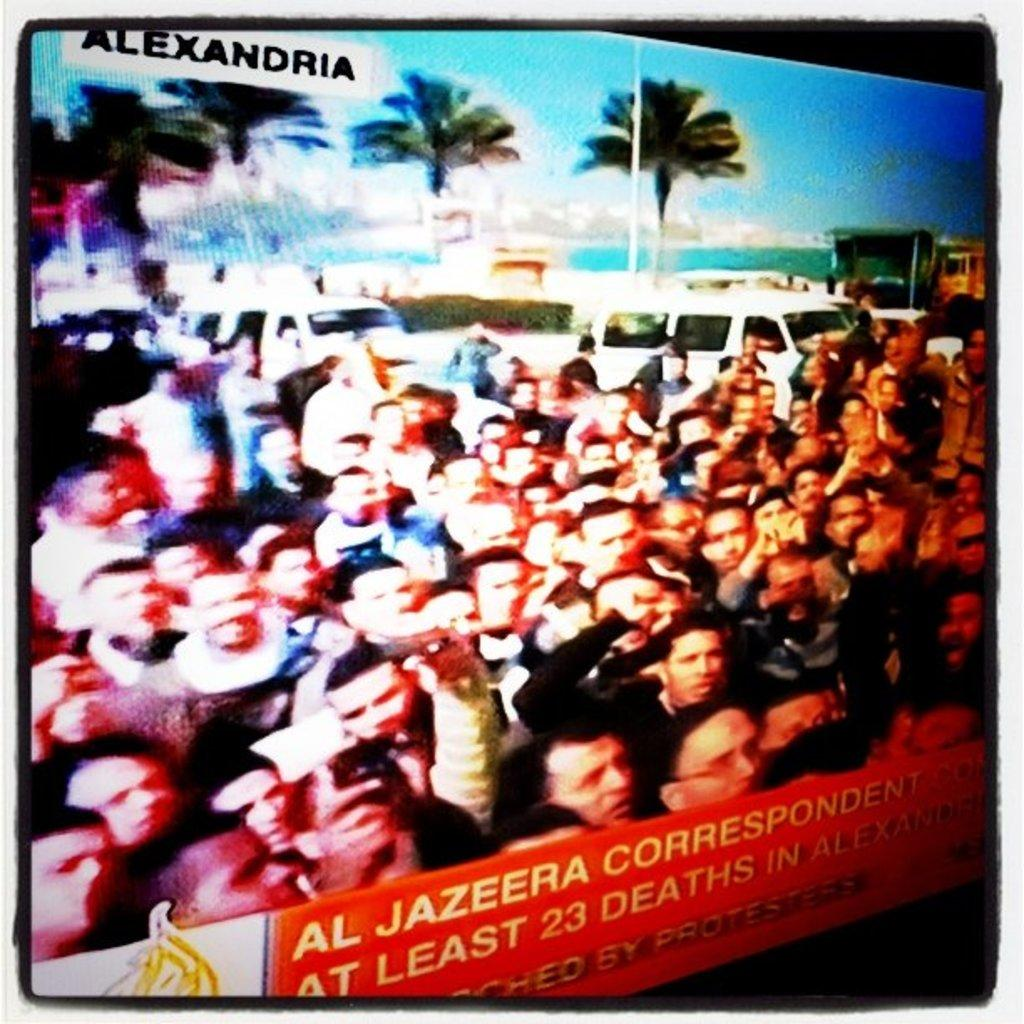Provide a one-sentence caption for the provided image. a TV screen of a crowd of people, with Alexandria and reporter AL JAZEERA talking about 23 deaths. 